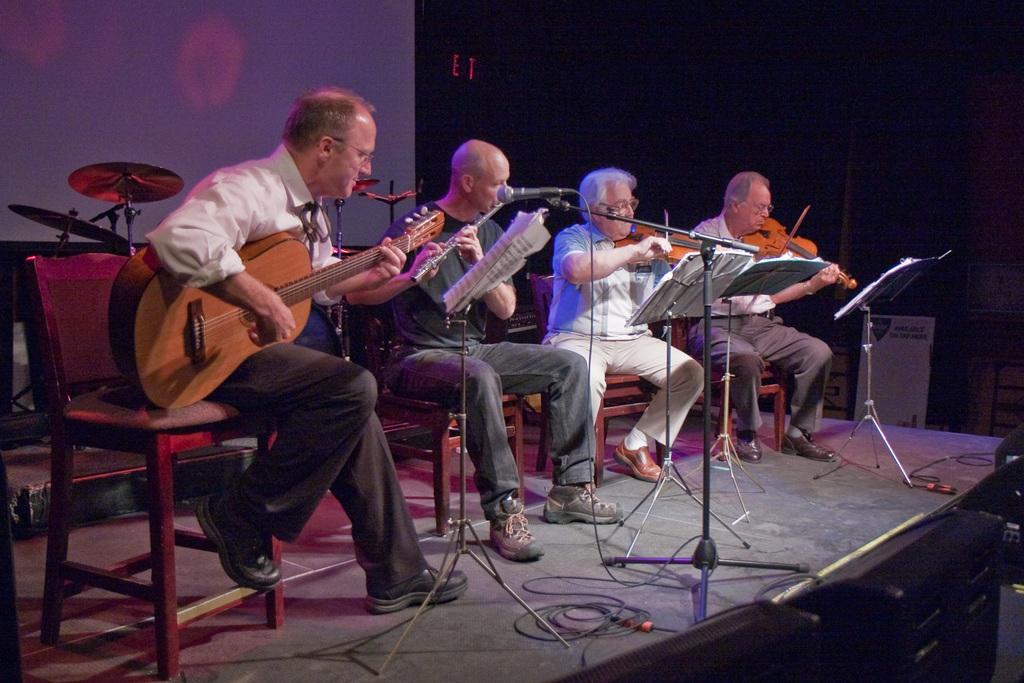What are the people in the image doing? The people in the image are playing musical instruments. What musical instruments can be seen in the image? There is a drum and a crash cymbal in the background of the image. What objects are present in the background of the image? There is a screen, a chair, and cables in the background of the image. What year is depicted in the image? The image does not depict a specific year; it shows a group of people playing musical instruments. What type of crime is being committed in the image? There is no crime being committed in the image; it features a group of people playing music. 